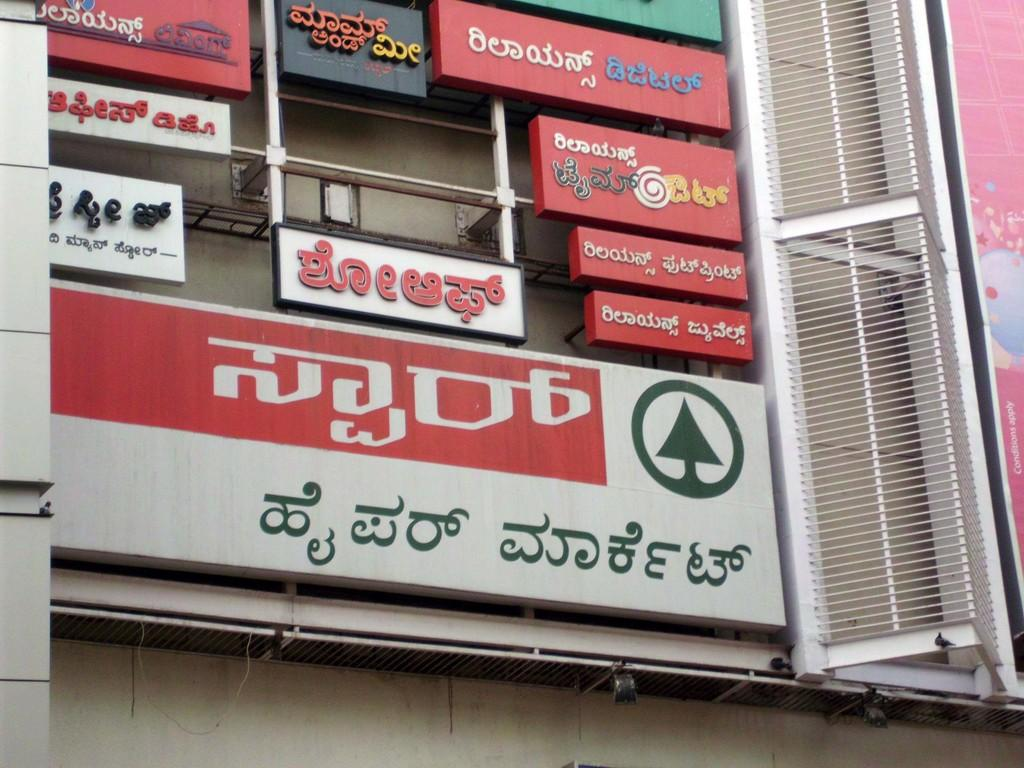What is the main subject of the image? The main subject of the image is a building. What can be seen on the building? There are advertisement boards on the building. How many clocks are hanging from the building in the image? There are no clocks visible in the image; only the building and advertisement boards are present. Is there a hose attached to the building for watering plants? There is no hose present in the image. 